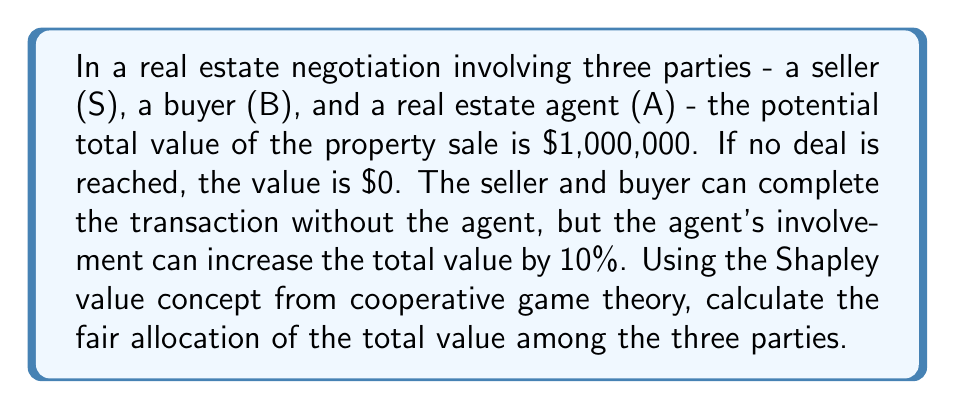Teach me how to tackle this problem. To solve this problem using cooperative game theory, we'll use the Shapley value concept to determine the fair allocation of the total value among the three parties. The Shapley value considers all possible coalitions and the marginal contributions of each player.

Step 1: Define the characteristic function v(S) for all possible coalitions:
- v({}) = $0 (empty coalition)
- v({S}) = v({B}) = v({A}) = $0 (individual parties can't create value alone)
- v({S,B}) = $1,000,000 (seller and buyer can complete the transaction)
- v({S,A}) = v({B,A}) = $0 (agent needs both seller and buyer to create value)
- v({S,B,A}) = $1,100,000 (all parties together create 10% more value)

Step 2: Calculate the marginal contributions for each party in all possible orderings:

1. S, B, A: S: $0, B: $1,000,000, A: $100,000
2. S, A, B: S: $0, A: $0, B: $1,100,000
3. B, S, A: B: $0, S: $1,000,000, A: $100,000
4. B, A, S: B: $0, A: $0, S: $1,100,000
5. A, S, B: A: $0, S: $0, B: $1,100,000
6. A, B, S: A: $0, B: $0, S: $1,100,000

Step 3: Calculate the Shapley value for each party by averaging their marginal contributions:

Seller (S):
$\phi_S = \frac{1}{6}(0 + 0 + 1,000,000 + 1,100,000 + 0 + 1,100,000) = \frac{3,200,000}{6} = 533,333.33$

Buyer (B):
$\phi_B = \frac{1}{6}(1,000,000 + 1,100,000 + 0 + 0 + 1,100,000 + 0) = \frac{3,200,000}{6} = 533,333.33$

Agent (A):
$\phi_A = \frac{1}{6}(100,000 + 0 + 100,000 + 0 + 0 + 0) = \frac{200,000}{6} = 33,333.33$

The Shapley values represent the fair allocation of the total value among the three parties based on their marginal contributions to all possible coalitions.
Answer: The fair allocation of the total value based on the Shapley value concept is:

Seller (S): $533,333.33
Buyer (B): $533,333.33
Agent (A): $33,333.33 